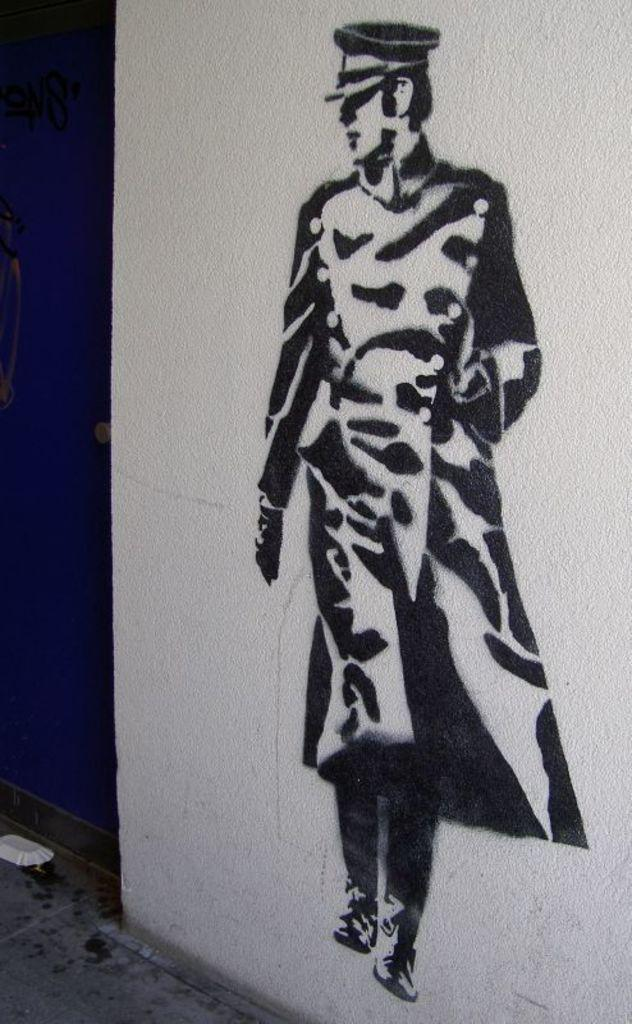What is being depicted on the white wall in the image? There is a human painting on a white wall in the image. What type of surface is visible beneath the wall? There is a floor visible in the image. What type of container is present in the image? There is a paper cup in the image. What color can be seen on the right side of the image? There is a blue color visible on the right side of the image. What is the name of the drain featured in the image? There is no drain present in the image. How much dirt can be seen on the floor in the image? There is no dirt visible on the floor in the image. 